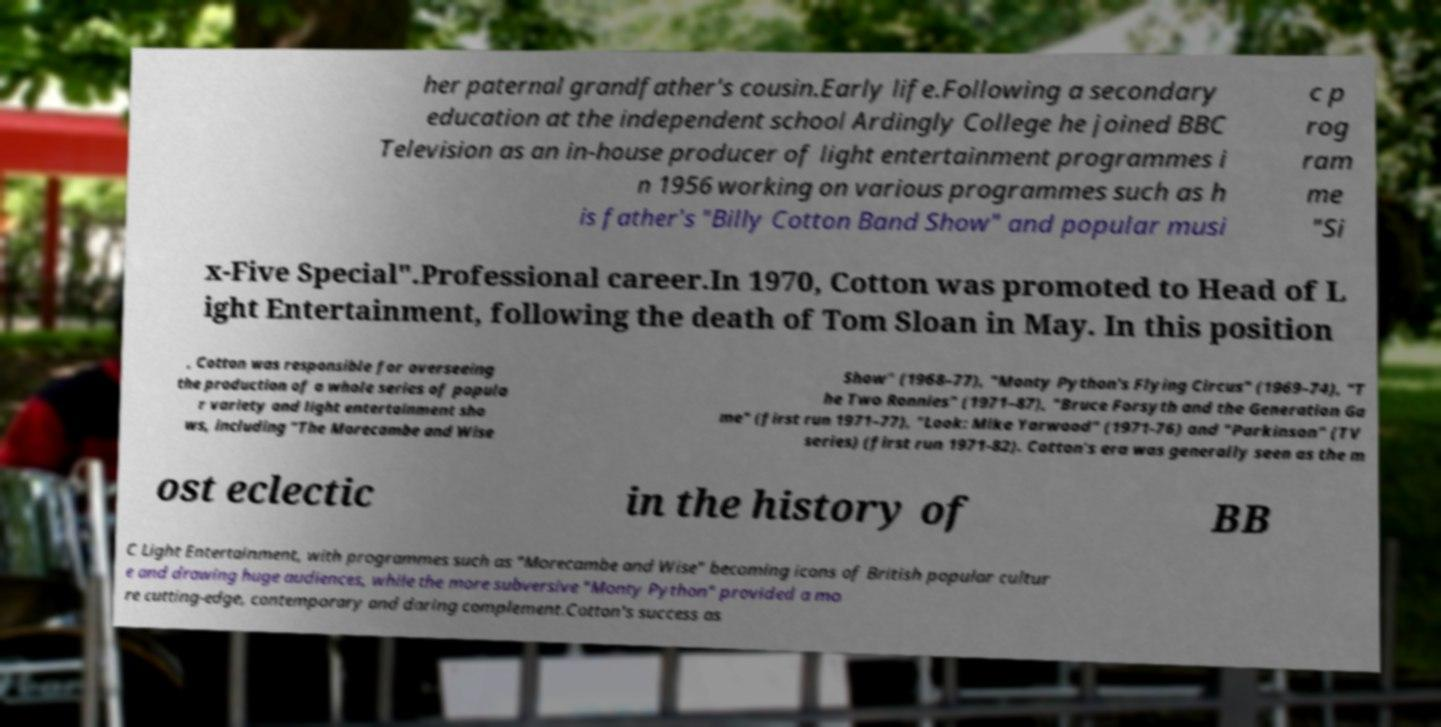Please identify and transcribe the text found in this image. her paternal grandfather's cousin.Early life.Following a secondary education at the independent school Ardingly College he joined BBC Television as an in-house producer of light entertainment programmes i n 1956 working on various programmes such as h is father's "Billy Cotton Band Show" and popular musi c p rog ram me "Si x-Five Special".Professional career.In 1970, Cotton was promoted to Head of L ight Entertainment, following the death of Tom Sloan in May. In this position , Cotton was responsible for overseeing the production of a whole series of popula r variety and light entertainment sho ws, including "The Morecambe and Wise Show" (1968–77), "Monty Python's Flying Circus" (1969–74), "T he Two Ronnies" (1971–87), "Bruce Forsyth and the Generation Ga me" (first run 1971–77), "Look: Mike Yarwood" (1971-76) and "Parkinson" (TV series) (first run 1971-82). Cotton's era was generally seen as the m ost eclectic in the history of BB C Light Entertainment, with programmes such as "Morecambe and Wise" becoming icons of British popular cultur e and drawing huge audiences, while the more subversive "Monty Python" provided a mo re cutting-edge, contemporary and daring complement.Cotton's success as 